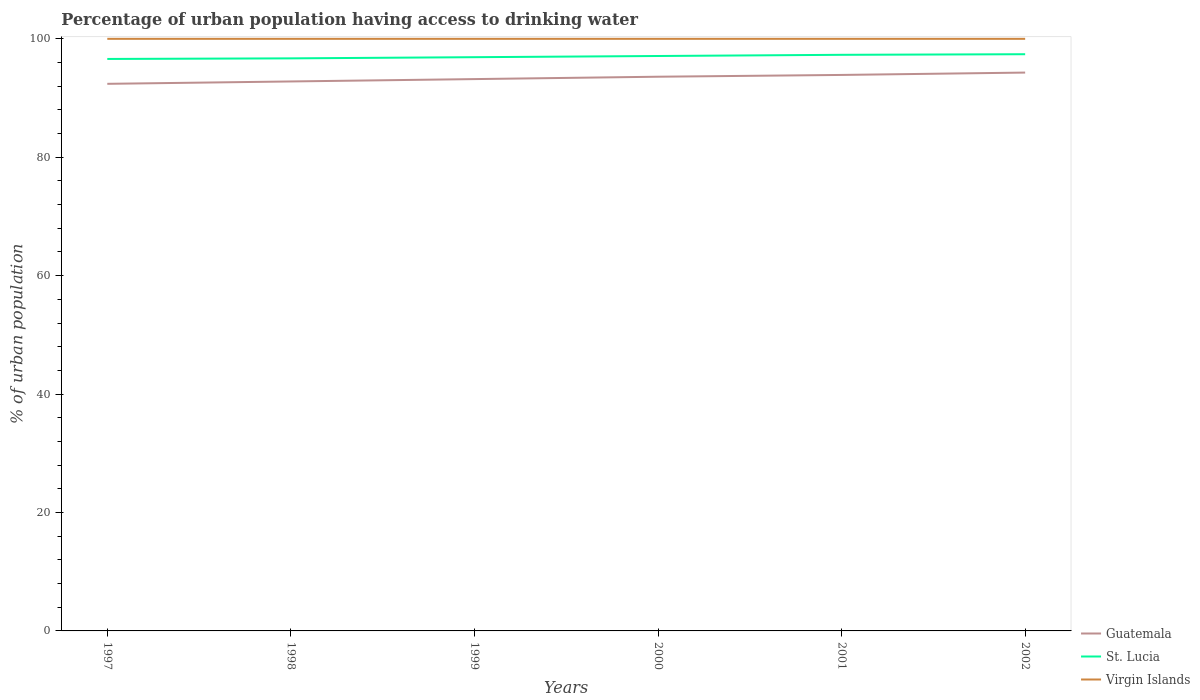Does the line corresponding to Virgin Islands intersect with the line corresponding to St. Lucia?
Offer a very short reply. No. Across all years, what is the maximum percentage of urban population having access to drinking water in Guatemala?
Offer a terse response. 92.4. What is the total percentage of urban population having access to drinking water in St. Lucia in the graph?
Your answer should be compact. -0.6. What is the difference between the highest and the second highest percentage of urban population having access to drinking water in Virgin Islands?
Your response must be concise. 0. What is the difference between the highest and the lowest percentage of urban population having access to drinking water in Guatemala?
Provide a succinct answer. 3. How many lines are there?
Your response must be concise. 3. What is the difference between two consecutive major ticks on the Y-axis?
Make the answer very short. 20. Are the values on the major ticks of Y-axis written in scientific E-notation?
Make the answer very short. No. Does the graph contain any zero values?
Your answer should be very brief. No. Does the graph contain grids?
Offer a terse response. No. How many legend labels are there?
Give a very brief answer. 3. What is the title of the graph?
Offer a terse response. Percentage of urban population having access to drinking water. Does "Israel" appear as one of the legend labels in the graph?
Your response must be concise. No. What is the label or title of the Y-axis?
Your answer should be compact. % of urban population. What is the % of urban population in Guatemala in 1997?
Offer a very short reply. 92.4. What is the % of urban population in St. Lucia in 1997?
Your answer should be compact. 96.6. What is the % of urban population of Virgin Islands in 1997?
Offer a terse response. 100. What is the % of urban population in Guatemala in 1998?
Your answer should be very brief. 92.8. What is the % of urban population of St. Lucia in 1998?
Make the answer very short. 96.7. What is the % of urban population in Guatemala in 1999?
Provide a short and direct response. 93.2. What is the % of urban population of St. Lucia in 1999?
Provide a short and direct response. 96.9. What is the % of urban population of Virgin Islands in 1999?
Provide a succinct answer. 100. What is the % of urban population in Guatemala in 2000?
Ensure brevity in your answer.  93.6. What is the % of urban population of St. Lucia in 2000?
Your answer should be very brief. 97.1. What is the % of urban population of Virgin Islands in 2000?
Your answer should be compact. 100. What is the % of urban population in Guatemala in 2001?
Provide a short and direct response. 93.9. What is the % of urban population of St. Lucia in 2001?
Your answer should be very brief. 97.3. What is the % of urban population of Guatemala in 2002?
Make the answer very short. 94.3. What is the % of urban population of St. Lucia in 2002?
Provide a short and direct response. 97.4. Across all years, what is the maximum % of urban population of Guatemala?
Ensure brevity in your answer.  94.3. Across all years, what is the maximum % of urban population of St. Lucia?
Give a very brief answer. 97.4. Across all years, what is the minimum % of urban population in Guatemala?
Offer a terse response. 92.4. Across all years, what is the minimum % of urban population in St. Lucia?
Your answer should be very brief. 96.6. Across all years, what is the minimum % of urban population in Virgin Islands?
Your answer should be compact. 100. What is the total % of urban population of Guatemala in the graph?
Give a very brief answer. 560.2. What is the total % of urban population of St. Lucia in the graph?
Offer a very short reply. 582. What is the total % of urban population of Virgin Islands in the graph?
Your response must be concise. 600. What is the difference between the % of urban population of Guatemala in 1997 and that in 1998?
Ensure brevity in your answer.  -0.4. What is the difference between the % of urban population of Virgin Islands in 1997 and that in 1998?
Offer a terse response. 0. What is the difference between the % of urban population in Guatemala in 1997 and that in 2000?
Provide a short and direct response. -1.2. What is the difference between the % of urban population of St. Lucia in 1997 and that in 2000?
Provide a succinct answer. -0.5. What is the difference between the % of urban population of Virgin Islands in 1997 and that in 2000?
Provide a short and direct response. 0. What is the difference between the % of urban population of St. Lucia in 1997 and that in 2001?
Provide a succinct answer. -0.7. What is the difference between the % of urban population of Virgin Islands in 1997 and that in 2002?
Your response must be concise. 0. What is the difference between the % of urban population of Guatemala in 1998 and that in 1999?
Offer a very short reply. -0.4. What is the difference between the % of urban population in St. Lucia in 1998 and that in 1999?
Keep it short and to the point. -0.2. What is the difference between the % of urban population in St. Lucia in 1998 and that in 2000?
Your answer should be compact. -0.4. What is the difference between the % of urban population of Virgin Islands in 1998 and that in 2000?
Offer a very short reply. 0. What is the difference between the % of urban population in Virgin Islands in 1998 and that in 2001?
Make the answer very short. 0. What is the difference between the % of urban population in St. Lucia in 1998 and that in 2002?
Your answer should be compact. -0.7. What is the difference between the % of urban population of Virgin Islands in 1998 and that in 2002?
Keep it short and to the point. 0. What is the difference between the % of urban population in Virgin Islands in 1999 and that in 2000?
Provide a short and direct response. 0. What is the difference between the % of urban population of St. Lucia in 1999 and that in 2001?
Your answer should be compact. -0.4. What is the difference between the % of urban population in Guatemala in 2000 and that in 2001?
Provide a short and direct response. -0.3. What is the difference between the % of urban population in St. Lucia in 2000 and that in 2002?
Provide a succinct answer. -0.3. What is the difference between the % of urban population of Virgin Islands in 2000 and that in 2002?
Give a very brief answer. 0. What is the difference between the % of urban population in St. Lucia in 2001 and that in 2002?
Your response must be concise. -0.1. What is the difference between the % of urban population in Virgin Islands in 2001 and that in 2002?
Your answer should be very brief. 0. What is the difference between the % of urban population in St. Lucia in 1997 and the % of urban population in Virgin Islands in 1998?
Your answer should be very brief. -3.4. What is the difference between the % of urban population in Guatemala in 1997 and the % of urban population in St. Lucia in 1999?
Make the answer very short. -4.5. What is the difference between the % of urban population in Guatemala in 1997 and the % of urban population in Virgin Islands in 1999?
Provide a short and direct response. -7.6. What is the difference between the % of urban population in Guatemala in 1997 and the % of urban population in St. Lucia in 2000?
Keep it short and to the point. -4.7. What is the difference between the % of urban population of Guatemala in 1997 and the % of urban population of Virgin Islands in 2000?
Keep it short and to the point. -7.6. What is the difference between the % of urban population of St. Lucia in 1997 and the % of urban population of Virgin Islands in 2000?
Give a very brief answer. -3.4. What is the difference between the % of urban population of St. Lucia in 1997 and the % of urban population of Virgin Islands in 2001?
Offer a terse response. -3.4. What is the difference between the % of urban population of Guatemala in 1997 and the % of urban population of Virgin Islands in 2002?
Keep it short and to the point. -7.6. What is the difference between the % of urban population in St. Lucia in 1997 and the % of urban population in Virgin Islands in 2002?
Make the answer very short. -3.4. What is the difference between the % of urban population in Guatemala in 1998 and the % of urban population in St. Lucia in 1999?
Offer a very short reply. -4.1. What is the difference between the % of urban population in St. Lucia in 1998 and the % of urban population in Virgin Islands in 1999?
Keep it short and to the point. -3.3. What is the difference between the % of urban population in Guatemala in 1998 and the % of urban population in St. Lucia in 2000?
Give a very brief answer. -4.3. What is the difference between the % of urban population of Guatemala in 1998 and the % of urban population of Virgin Islands in 2000?
Make the answer very short. -7.2. What is the difference between the % of urban population in St. Lucia in 1998 and the % of urban population in Virgin Islands in 2001?
Your answer should be very brief. -3.3. What is the difference between the % of urban population of Guatemala in 1998 and the % of urban population of Virgin Islands in 2002?
Your response must be concise. -7.2. What is the difference between the % of urban population in St. Lucia in 1998 and the % of urban population in Virgin Islands in 2002?
Keep it short and to the point. -3.3. What is the difference between the % of urban population in Guatemala in 1999 and the % of urban population in Virgin Islands in 2000?
Give a very brief answer. -6.8. What is the difference between the % of urban population of Guatemala in 1999 and the % of urban population of Virgin Islands in 2002?
Keep it short and to the point. -6.8. What is the difference between the % of urban population of Guatemala in 2000 and the % of urban population of Virgin Islands in 2001?
Ensure brevity in your answer.  -6.4. What is the difference between the % of urban population in St. Lucia in 2000 and the % of urban population in Virgin Islands in 2001?
Offer a very short reply. -2.9. What is the difference between the % of urban population of Guatemala in 2000 and the % of urban population of Virgin Islands in 2002?
Provide a short and direct response. -6.4. What is the difference between the % of urban population of St. Lucia in 2000 and the % of urban population of Virgin Islands in 2002?
Offer a terse response. -2.9. What is the difference between the % of urban population of Guatemala in 2001 and the % of urban population of Virgin Islands in 2002?
Ensure brevity in your answer.  -6.1. What is the average % of urban population of Guatemala per year?
Your response must be concise. 93.37. What is the average % of urban population of St. Lucia per year?
Ensure brevity in your answer.  97. What is the average % of urban population in Virgin Islands per year?
Your answer should be compact. 100. In the year 1998, what is the difference between the % of urban population of Guatemala and % of urban population of St. Lucia?
Your answer should be very brief. -3.9. In the year 1998, what is the difference between the % of urban population in Guatemala and % of urban population in Virgin Islands?
Your answer should be compact. -7.2. In the year 1998, what is the difference between the % of urban population of St. Lucia and % of urban population of Virgin Islands?
Your response must be concise. -3.3. In the year 1999, what is the difference between the % of urban population in Guatemala and % of urban population in Virgin Islands?
Ensure brevity in your answer.  -6.8. In the year 1999, what is the difference between the % of urban population of St. Lucia and % of urban population of Virgin Islands?
Give a very brief answer. -3.1. In the year 2000, what is the difference between the % of urban population of Guatemala and % of urban population of St. Lucia?
Provide a short and direct response. -3.5. In the year 2000, what is the difference between the % of urban population of Guatemala and % of urban population of Virgin Islands?
Give a very brief answer. -6.4. In the year 2001, what is the difference between the % of urban population of Guatemala and % of urban population of St. Lucia?
Ensure brevity in your answer.  -3.4. In the year 2002, what is the difference between the % of urban population in St. Lucia and % of urban population in Virgin Islands?
Give a very brief answer. -2.6. What is the ratio of the % of urban population in St. Lucia in 1997 to that in 1998?
Your answer should be compact. 1. What is the ratio of the % of urban population in Virgin Islands in 1997 to that in 1998?
Provide a short and direct response. 1. What is the ratio of the % of urban population in Virgin Islands in 1997 to that in 1999?
Offer a terse response. 1. What is the ratio of the % of urban population in Guatemala in 1997 to that in 2000?
Provide a succinct answer. 0.99. What is the ratio of the % of urban population in St. Lucia in 1997 to that in 2000?
Your answer should be very brief. 0.99. What is the ratio of the % of urban population of Guatemala in 1997 to that in 2001?
Offer a terse response. 0.98. What is the ratio of the % of urban population of Virgin Islands in 1997 to that in 2001?
Your answer should be very brief. 1. What is the ratio of the % of urban population of Guatemala in 1997 to that in 2002?
Ensure brevity in your answer.  0.98. What is the ratio of the % of urban population in Guatemala in 1998 to that in 1999?
Provide a short and direct response. 1. What is the ratio of the % of urban population in St. Lucia in 1998 to that in 1999?
Make the answer very short. 1. What is the ratio of the % of urban population of St. Lucia in 1998 to that in 2000?
Your answer should be very brief. 1. What is the ratio of the % of urban population in Guatemala in 1998 to that in 2001?
Keep it short and to the point. 0.99. What is the ratio of the % of urban population of St. Lucia in 1998 to that in 2001?
Your answer should be compact. 0.99. What is the ratio of the % of urban population of Guatemala in 1998 to that in 2002?
Your answer should be very brief. 0.98. What is the ratio of the % of urban population in Virgin Islands in 1998 to that in 2002?
Give a very brief answer. 1. What is the ratio of the % of urban population of Virgin Islands in 1999 to that in 2000?
Your answer should be compact. 1. What is the ratio of the % of urban population of Guatemala in 1999 to that in 2001?
Offer a very short reply. 0.99. What is the ratio of the % of urban population of St. Lucia in 1999 to that in 2001?
Provide a succinct answer. 1. What is the ratio of the % of urban population of Guatemala in 1999 to that in 2002?
Your answer should be compact. 0.99. What is the ratio of the % of urban population of Guatemala in 2000 to that in 2001?
Your answer should be compact. 1. What is the ratio of the % of urban population in St. Lucia in 2000 to that in 2001?
Your response must be concise. 1. What is the ratio of the % of urban population in St. Lucia in 2001 to that in 2002?
Your answer should be very brief. 1. What is the difference between the highest and the second highest % of urban population in St. Lucia?
Your answer should be very brief. 0.1. What is the difference between the highest and the second highest % of urban population of Virgin Islands?
Make the answer very short. 0. What is the difference between the highest and the lowest % of urban population of Virgin Islands?
Your answer should be compact. 0. 